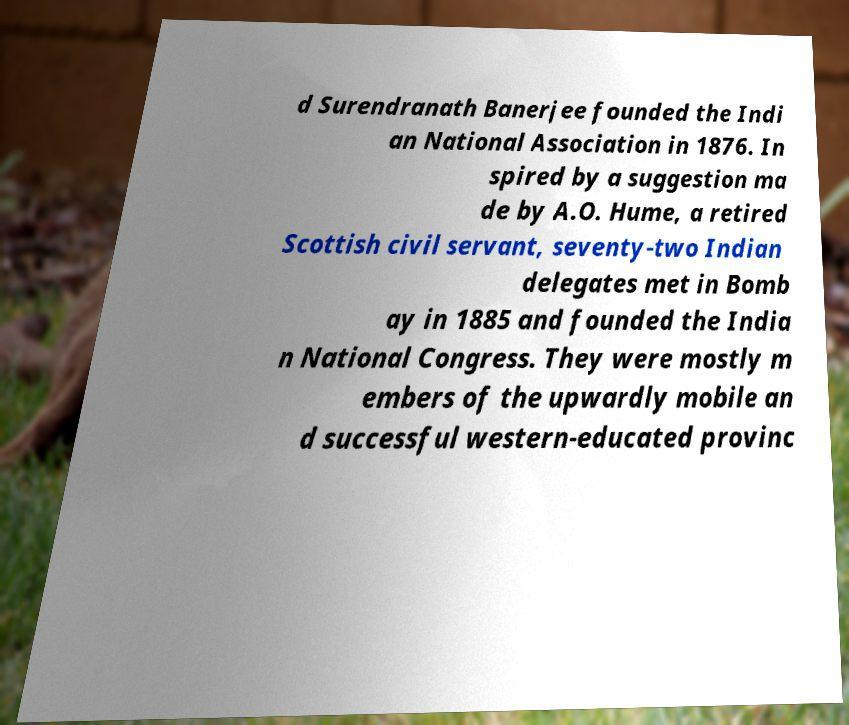Can you read and provide the text displayed in the image?This photo seems to have some interesting text. Can you extract and type it out for me? d Surendranath Banerjee founded the Indi an National Association in 1876. In spired by a suggestion ma de by A.O. Hume, a retired Scottish civil servant, seventy-two Indian delegates met in Bomb ay in 1885 and founded the India n National Congress. They were mostly m embers of the upwardly mobile an d successful western-educated provinc 